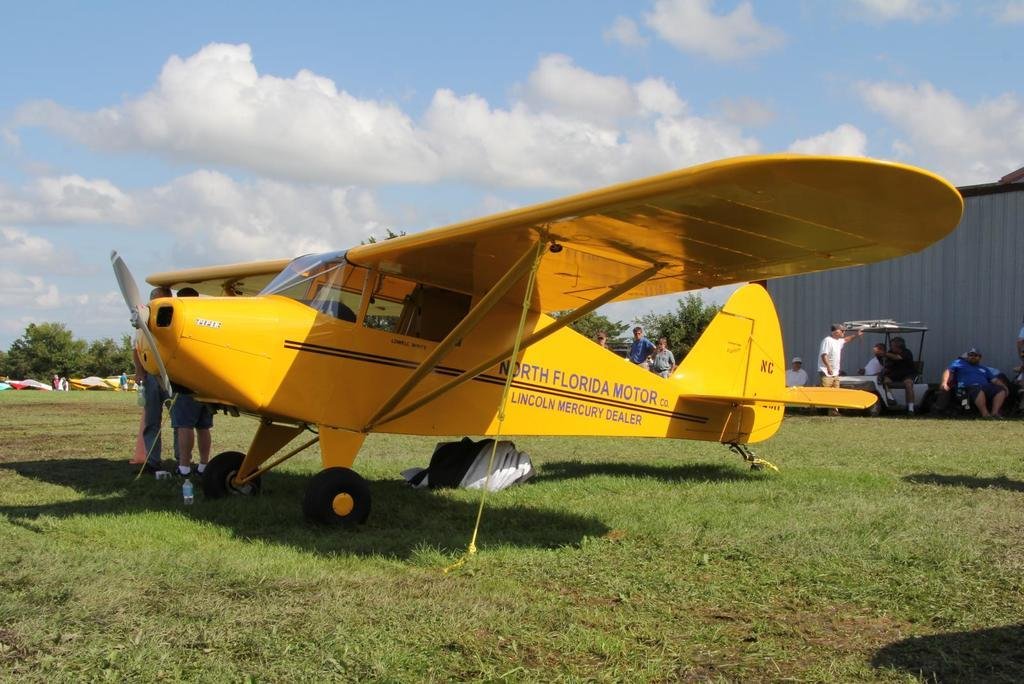<image>
Present a compact description of the photo's key features. A yellow prop plane advertising North Florida Motor Lincoln Mercury Dealer on the side of it is on the grass near a hanger. 